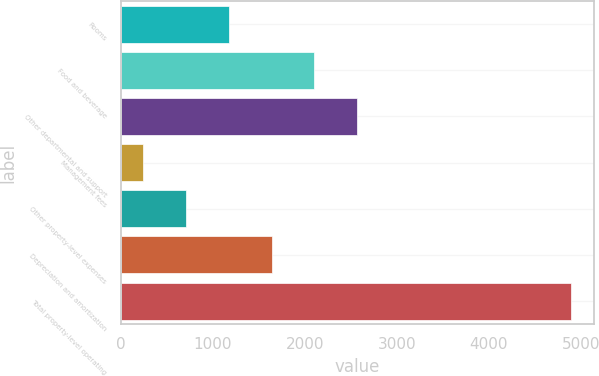Convert chart to OTSL. <chart><loc_0><loc_0><loc_500><loc_500><bar_chart><fcel>Rooms<fcel>Food and beverage<fcel>Other departmental and support<fcel>Management fees<fcel>Other property-level expenses<fcel>Depreciation and amortization<fcel>Total property-level operating<nl><fcel>1173.8<fcel>2104.6<fcel>2570<fcel>243<fcel>708.4<fcel>1639.2<fcel>4897<nl></chart> 